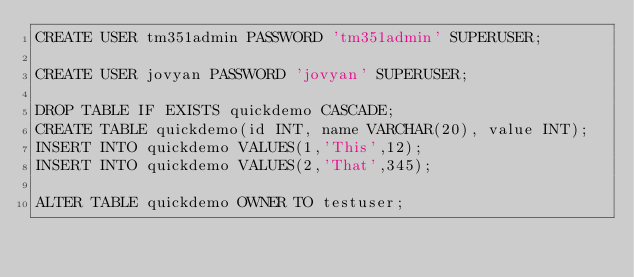<code> <loc_0><loc_0><loc_500><loc_500><_SQL_>CREATE USER tm351admin PASSWORD 'tm351admin' SUPERUSER;

CREATE USER jovyan PASSWORD 'jovyan' SUPERUSER;

DROP TABLE IF EXISTS quickdemo CASCADE;
CREATE TABLE quickdemo(id INT, name VARCHAR(20), value INT);
INSERT INTO quickdemo VALUES(1,'This',12);
INSERT INTO quickdemo VALUES(2,'That',345);

ALTER TABLE quickdemo OWNER TO testuser;

</code> 